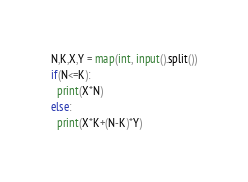<code> <loc_0><loc_0><loc_500><loc_500><_Python_>N,K,X,Y = map(int, input().split())
if(N<=K):
  print(X*N)
else:
  print(X*K+(N-K)*Y)
</code> 